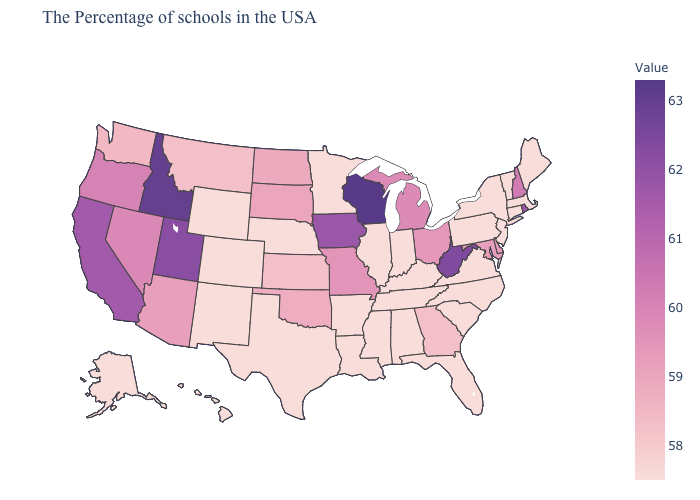Does the map have missing data?
Give a very brief answer. No. Does Georgia have a higher value than Alabama?
Keep it brief. Yes. Among the states that border Connecticut , which have the highest value?
Answer briefly. Rhode Island. Among the states that border Nevada , which have the lowest value?
Keep it brief. Arizona. Among the states that border Oregon , does Washington have the highest value?
Give a very brief answer. No. Among the states that border Texas , which have the highest value?
Short answer required. Oklahoma. 